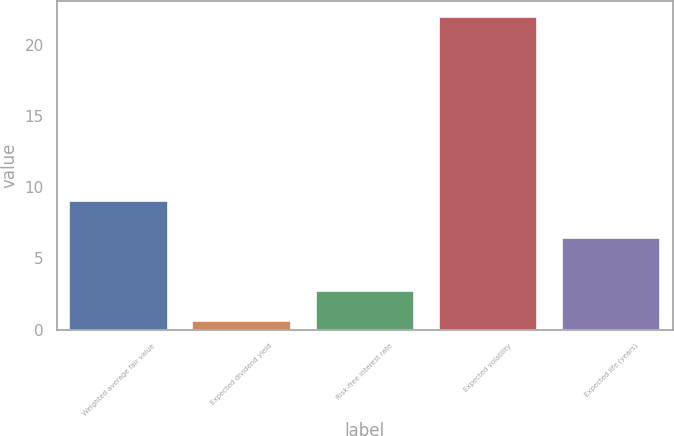Convert chart to OTSL. <chart><loc_0><loc_0><loc_500><loc_500><bar_chart><fcel>Weighted average fair value<fcel>Expected dividend yield<fcel>Risk-free interest rate<fcel>Expected volatility<fcel>Expected life (years)<nl><fcel>9.06<fcel>0.58<fcel>2.72<fcel>22<fcel>6.42<nl></chart> 